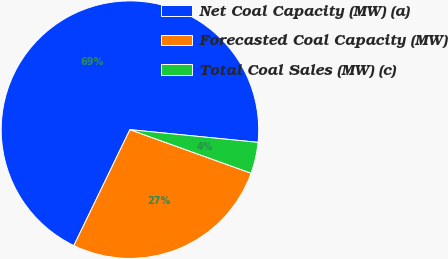Convert chart to OTSL. <chart><loc_0><loc_0><loc_500><loc_500><pie_chart><fcel>Net Coal Capacity (MW) (a)<fcel>Forecasted Coal Capacity (MW)<fcel>Total Coal Sales (MW) (c)<nl><fcel>69.4%<fcel>26.68%<fcel>3.92%<nl></chart> 